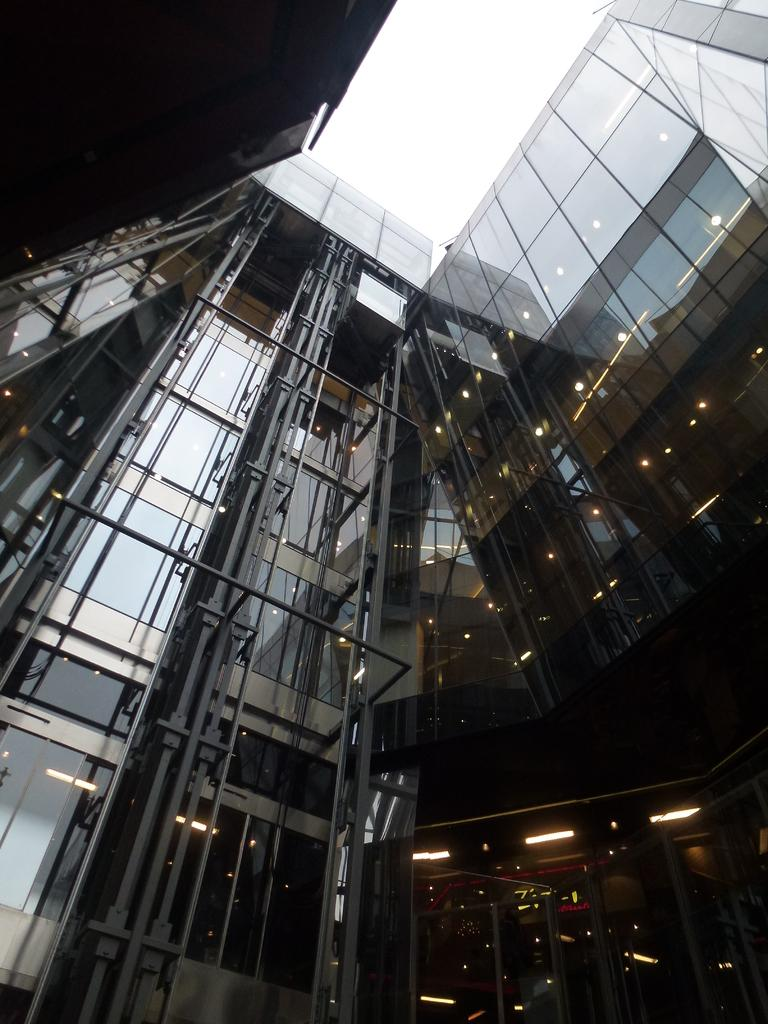What is the main structure in the image? There is a building in the image. What is attached to the building? There are glasses on the building. What can be seen inside the building? Lights are visible inside the building. What is visible in the background of the image? The sky is visible in the background of the image. What type of meat is being served on the board in the image? There is no meat or board present in the image; it features a building with glasses and lights. 